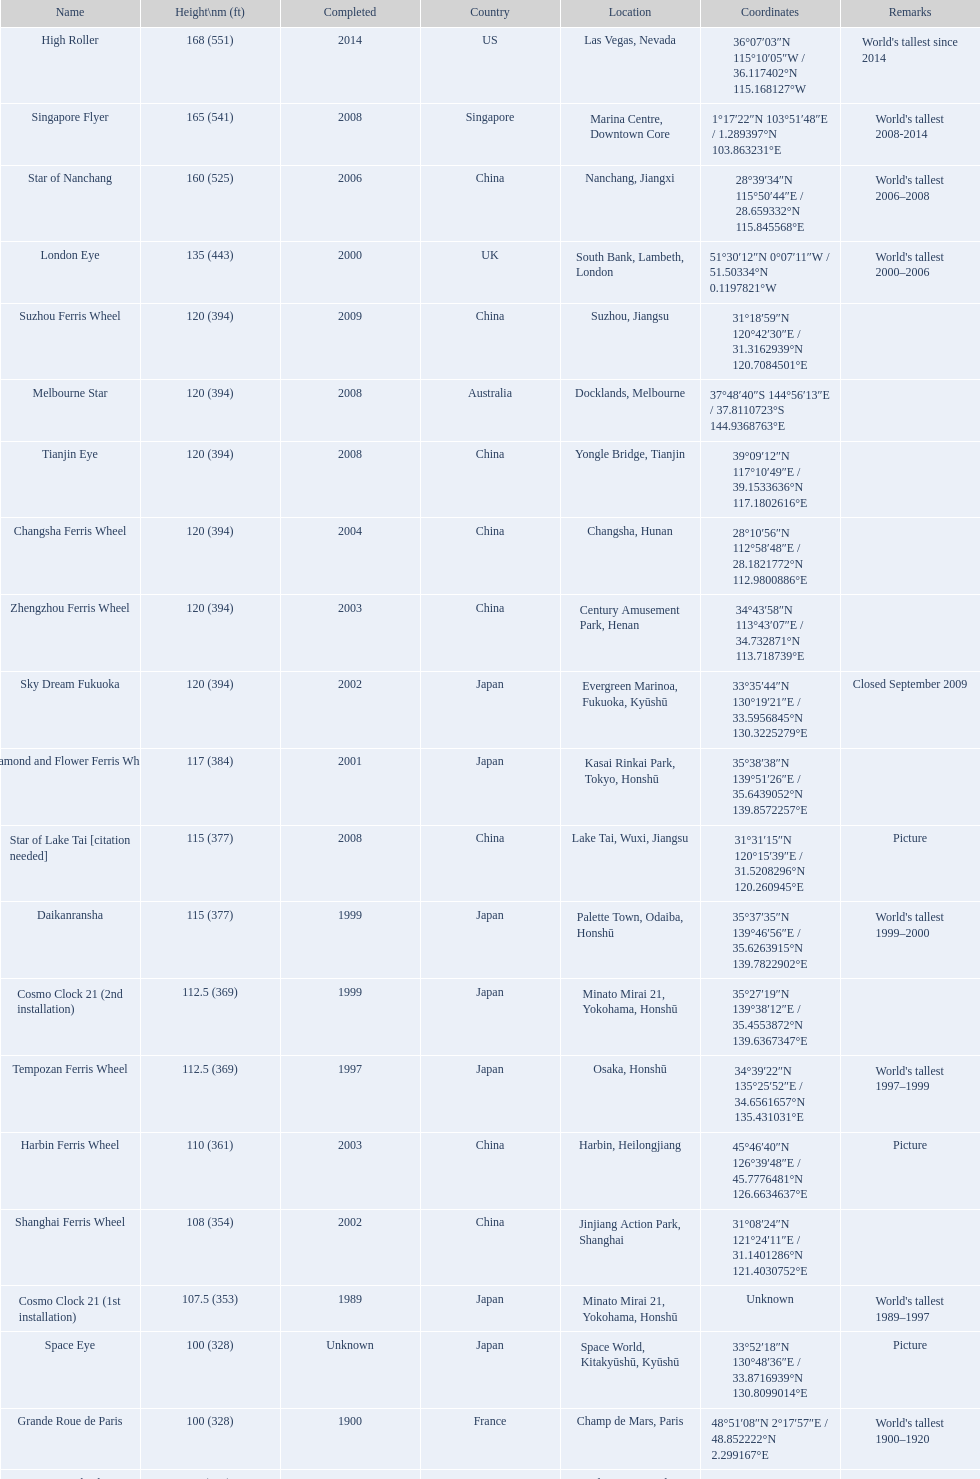Which country had the most roller coasters over 80 feet in height in 2008? China. 